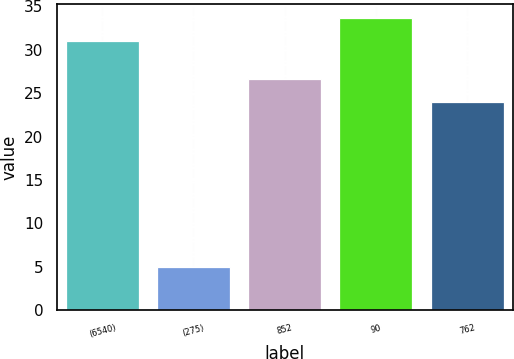<chart> <loc_0><loc_0><loc_500><loc_500><bar_chart><fcel>(6540)<fcel>(275)<fcel>852<fcel>90<fcel>762<nl><fcel>31<fcel>5<fcel>26.6<fcel>33.6<fcel>24<nl></chart> 